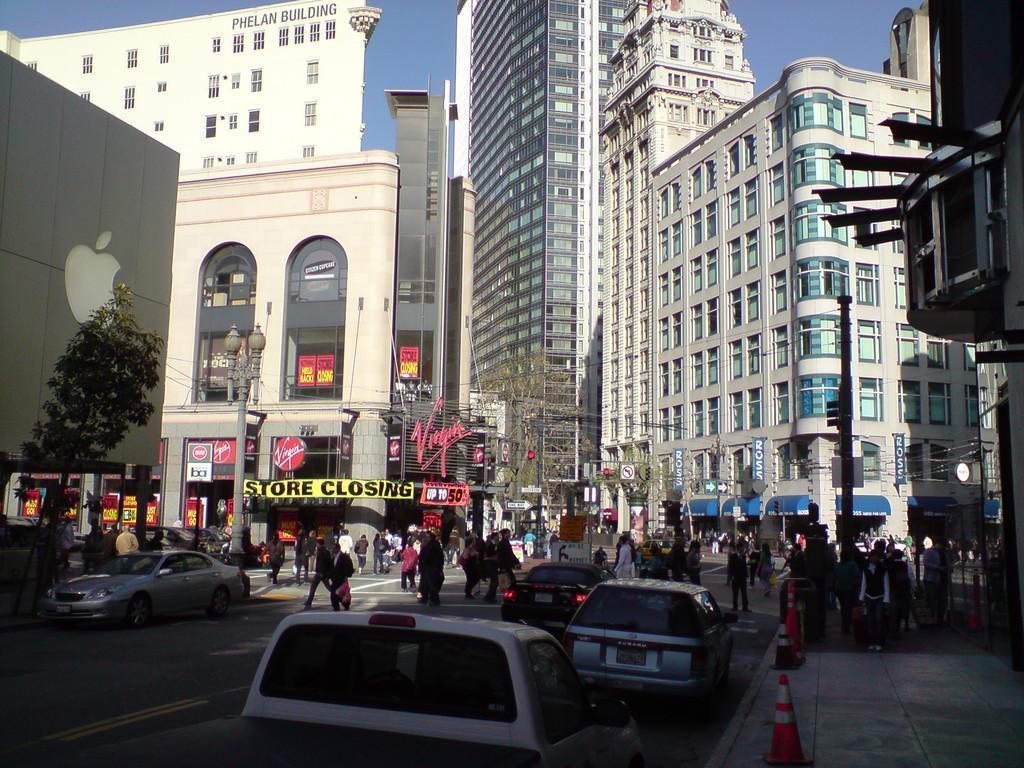Could you give a brief overview of what you see in this image? In this image there are vehicles moving on the road and there are persons standing and walking. In the background there are buildings, there are boards with some text and there are trees and the sky is cloudy. 